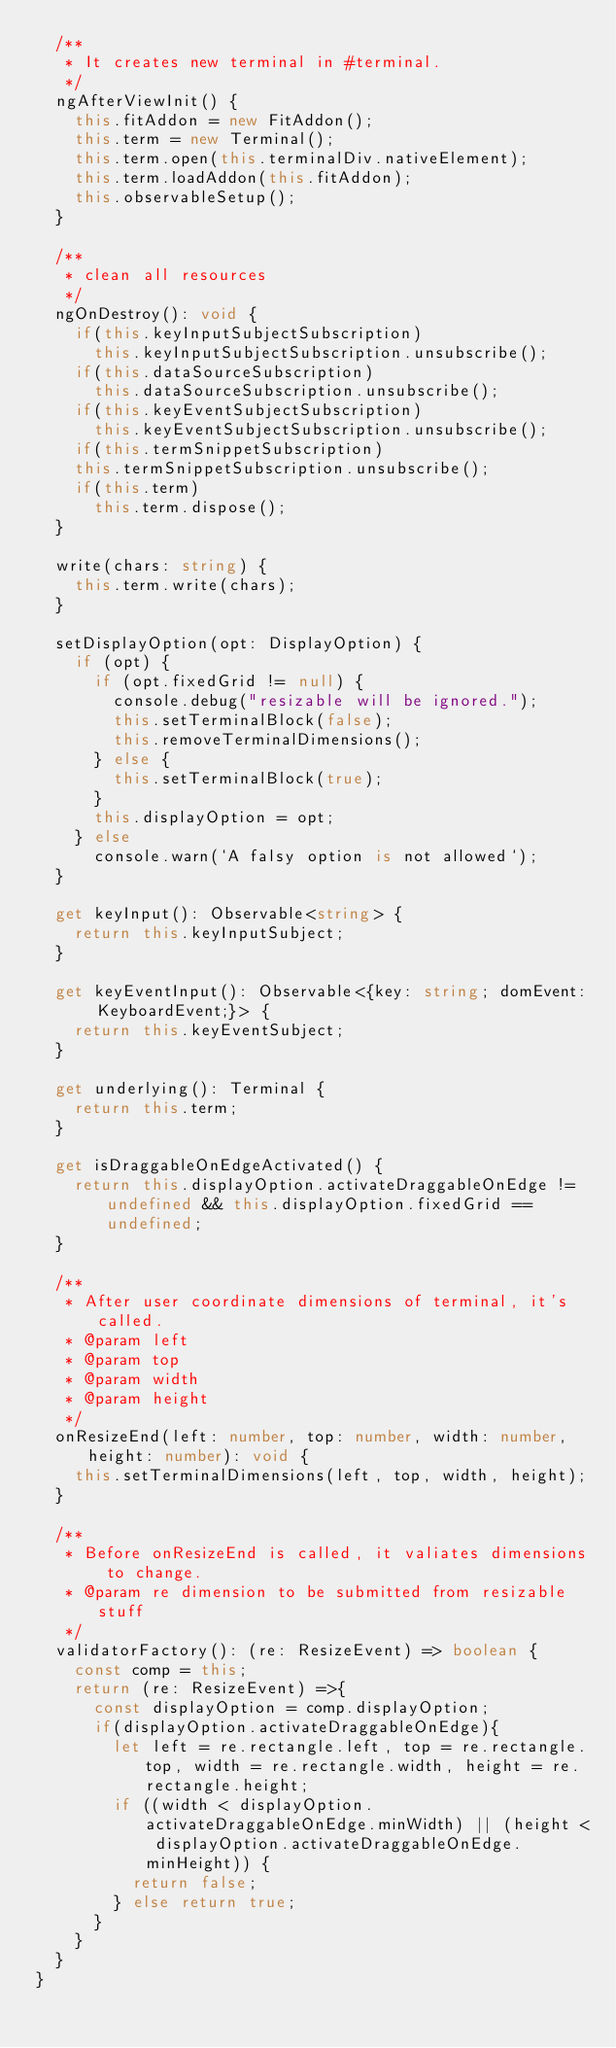<code> <loc_0><loc_0><loc_500><loc_500><_TypeScript_>  /**
   * It creates new terminal in #terminal.
   */
  ngAfterViewInit() {
    this.fitAddon = new FitAddon();
    this.term = new Terminal();
    this.term.open(this.terminalDiv.nativeElement);
    this.term.loadAddon(this.fitAddon);
    this.observableSetup();
  }

  /**
   * clean all resources
   */
  ngOnDestroy(): void {
    if(this.keyInputSubjectSubscription)
      this.keyInputSubjectSubscription.unsubscribe();
    if(this.dataSourceSubscription)
      this.dataSourceSubscription.unsubscribe();
    if(this.keyEventSubjectSubscription)
      this.keyEventSubjectSubscription.unsubscribe();
    if(this.termSnippetSubscription)
    this.termSnippetSubscription.unsubscribe();
    if(this.term)
      this.term.dispose();
  }

  write(chars: string) {
    this.term.write(chars);
  }

  setDisplayOption(opt: DisplayOption) {
    if (opt) {
      if (opt.fixedGrid != null) {
        console.debug("resizable will be ignored.");
        this.setTerminalBlock(false);
        this.removeTerminalDimensions();
      } else {
        this.setTerminalBlock(true);
      }
      this.displayOption = opt;
    } else
      console.warn(`A falsy option is not allowed`);
  }

  get keyInput(): Observable<string> {
    return this.keyInputSubject;
  }

  get keyEventInput(): Observable<{key: string; domEvent: KeyboardEvent;}> {
    return this.keyEventSubject;
  }

  get underlying(): Terminal {
    return this.term;
  }

  get isDraggableOnEdgeActivated() {
    return this.displayOption.activateDraggableOnEdge != undefined && this.displayOption.fixedGrid == undefined;
  }

  /**
   * After user coordinate dimensions of terminal, it's called.
   * @param left 
   * @param top 
   * @param width 
   * @param height 
   */
  onResizeEnd(left: number, top: number, width: number, height: number): void {
    this.setTerminalDimensions(left, top, width, height);
  }

  /**
   * Before onResizeEnd is called, it valiates dimensions to change.
   * @param re dimension to be submitted from resizable stuff
   */
  validatorFactory(): (re: ResizeEvent) => boolean {
    const comp = this;
    return (re: ResizeEvent) =>{ 
      const displayOption = comp.displayOption;
      if(displayOption.activateDraggableOnEdge){
        let left = re.rectangle.left, top = re.rectangle.top, width = re.rectangle.width, height = re.rectangle.height;
        if ((width < displayOption.activateDraggableOnEdge.minWidth) || (height < displayOption.activateDraggableOnEdge.minHeight)) {
          return false;
        } else return true;
      }
    }
  }
}
</code> 